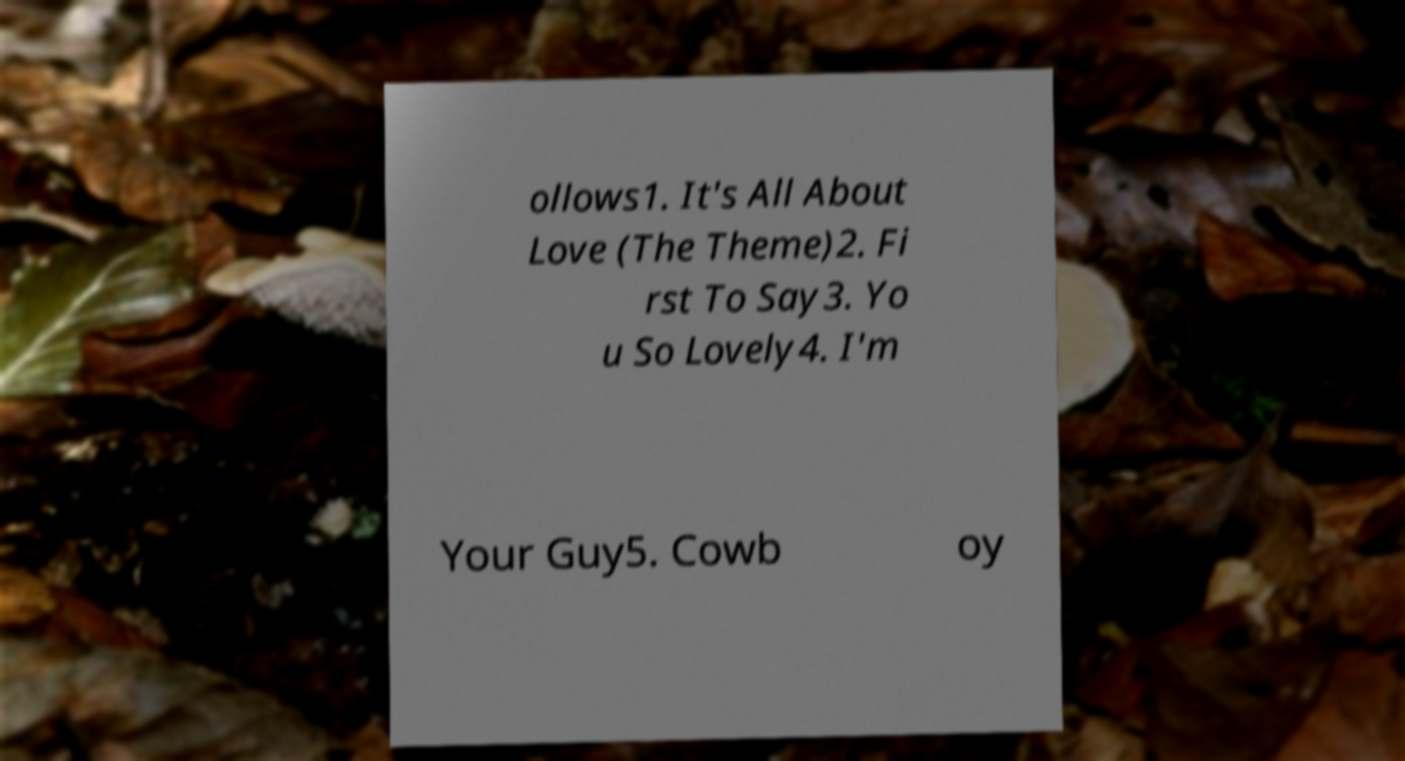What messages or text are displayed in this image? I need them in a readable, typed format. ollows1. It's All About Love (The Theme)2. Fi rst To Say3. Yo u So Lovely4. I'm Your Guy5. Cowb oy 